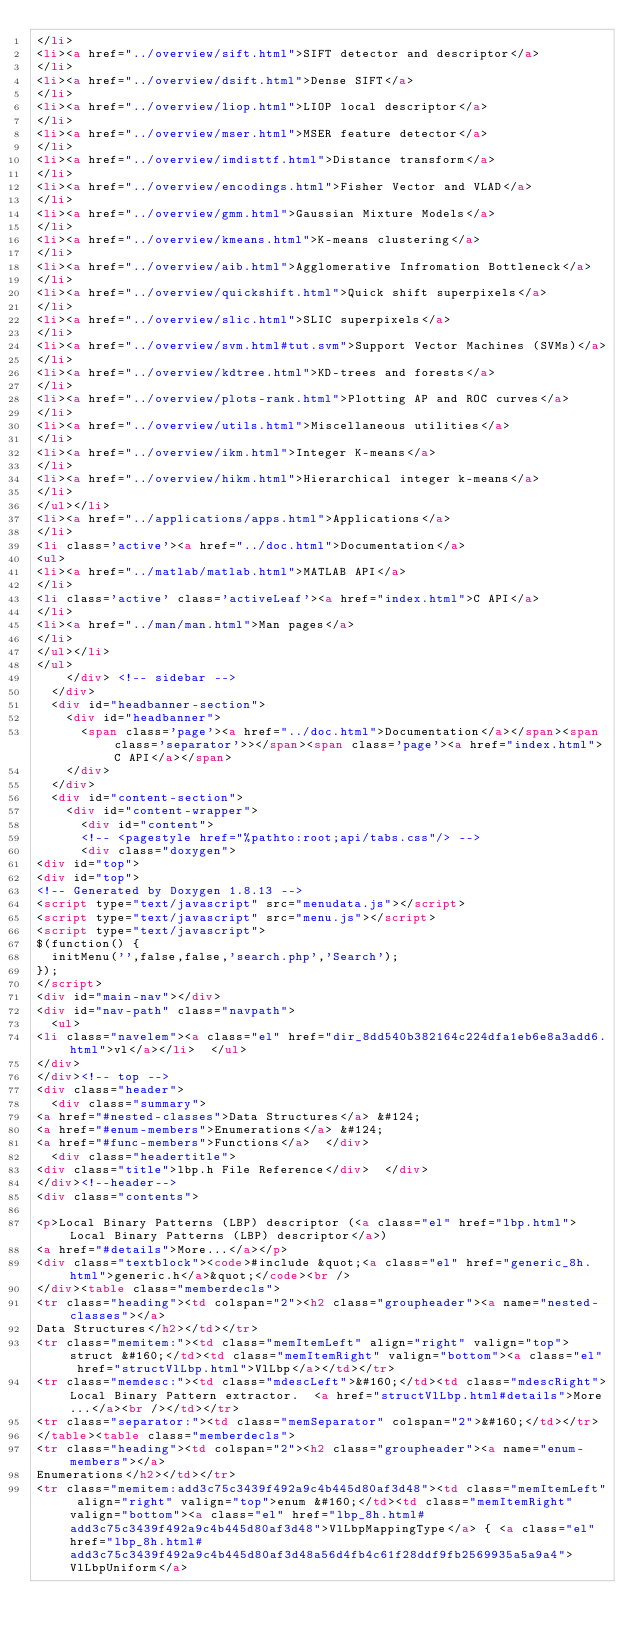<code> <loc_0><loc_0><loc_500><loc_500><_HTML_></li>
<li><a href="../overview/sift.html">SIFT detector and descriptor</a>
</li>
<li><a href="../overview/dsift.html">Dense SIFT</a>
</li>
<li><a href="../overview/liop.html">LIOP local descriptor</a>
</li>
<li><a href="../overview/mser.html">MSER feature detector</a>
</li>
<li><a href="../overview/imdisttf.html">Distance transform</a>
</li>
<li><a href="../overview/encodings.html">Fisher Vector and VLAD</a>
</li>
<li><a href="../overview/gmm.html">Gaussian Mixture Models</a>
</li>
<li><a href="../overview/kmeans.html">K-means clustering</a>
</li>
<li><a href="../overview/aib.html">Agglomerative Infromation Bottleneck</a>
</li>
<li><a href="../overview/quickshift.html">Quick shift superpixels</a>
</li>
<li><a href="../overview/slic.html">SLIC superpixels</a>
</li>
<li><a href="../overview/svm.html#tut.svm">Support Vector Machines (SVMs)</a>
</li>
<li><a href="../overview/kdtree.html">KD-trees and forests</a>
</li>
<li><a href="../overview/plots-rank.html">Plotting AP and ROC curves</a>
</li>
<li><a href="../overview/utils.html">Miscellaneous utilities</a>
</li>
<li><a href="../overview/ikm.html">Integer K-means</a>
</li>
<li><a href="../overview/hikm.html">Hierarchical integer k-means</a>
</li>
</ul></li>
<li><a href="../applications/apps.html">Applications</a>
</li>
<li class='active'><a href="../doc.html">Documentation</a>
<ul>
<li><a href="../matlab/matlab.html">MATLAB API</a>
</li>
<li class='active' class='activeLeaf'><a href="index.html">C API</a>
</li>
<li><a href="../man/man.html">Man pages</a>
</li>
</ul></li>
</ul>
    </div> <!-- sidebar -->
  </div>
  <div id="headbanner-section">
    <div id="headbanner">
      <span class='page'><a href="../doc.html">Documentation</a></span><span class='separator'>></span><span class='page'><a href="index.html">C API</a></span>
    </div>
  </div>
  <div id="content-section">
    <div id="content-wrapper">
      <div id="content">
      <!-- <pagestyle href="%pathto:root;api/tabs.css"/> -->
      <div class="doxygen">
<div id="top">
<div id="top">
<!-- Generated by Doxygen 1.8.13 -->
<script type="text/javascript" src="menudata.js"></script>
<script type="text/javascript" src="menu.js"></script>
<script type="text/javascript">
$(function() {
  initMenu('',false,false,'search.php','Search');
});
</script>
<div id="main-nav"></div>
<div id="nav-path" class="navpath">
  <ul>
<li class="navelem"><a class="el" href="dir_8dd540b382164c224dfa1eb6e8a3add6.html">vl</a></li>  </ul>
</div>
</div><!-- top -->
<div class="header">
  <div class="summary">
<a href="#nested-classes">Data Structures</a> &#124;
<a href="#enum-members">Enumerations</a> &#124;
<a href="#func-members">Functions</a>  </div>
  <div class="headertitle">
<div class="title">lbp.h File Reference</div>  </div>
</div><!--header-->
<div class="contents">

<p>Local Binary Patterns (LBP) descriptor (<a class="el" href="lbp.html">Local Binary Patterns (LBP) descriptor</a>)  
<a href="#details">More...</a></p>
<div class="textblock"><code>#include &quot;<a class="el" href="generic_8h.html">generic.h</a>&quot;</code><br />
</div><table class="memberdecls">
<tr class="heading"><td colspan="2"><h2 class="groupheader"><a name="nested-classes"></a>
Data Structures</h2></td></tr>
<tr class="memitem:"><td class="memItemLeft" align="right" valign="top">struct &#160;</td><td class="memItemRight" valign="bottom"><a class="el" href="structVlLbp.html">VlLbp</a></td></tr>
<tr class="memdesc:"><td class="mdescLeft">&#160;</td><td class="mdescRight">Local Binary Pattern extractor.  <a href="structVlLbp.html#details">More...</a><br /></td></tr>
<tr class="separator:"><td class="memSeparator" colspan="2">&#160;</td></tr>
</table><table class="memberdecls">
<tr class="heading"><td colspan="2"><h2 class="groupheader"><a name="enum-members"></a>
Enumerations</h2></td></tr>
<tr class="memitem:add3c75c3439f492a9c4b445d80af3d48"><td class="memItemLeft" align="right" valign="top">enum &#160;</td><td class="memItemRight" valign="bottom"><a class="el" href="lbp_8h.html#add3c75c3439f492a9c4b445d80af3d48">VlLbpMappingType</a> { <a class="el" href="lbp_8h.html#add3c75c3439f492a9c4b445d80af3d48a56d4fb4c61f28ddf9fb2569935a5a9a4">VlLbpUniform</a></code> 